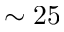Convert formula to latex. <formula><loc_0><loc_0><loc_500><loc_500>\sim 2 5</formula> 